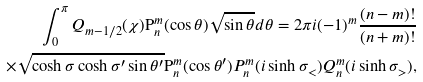Convert formula to latex. <formula><loc_0><loc_0><loc_500><loc_500>\int _ { 0 } ^ { \pi } Q _ { m - 1 / 2 } ( \chi ) { \mathrm P } _ { n } ^ { m } ( \cos \theta ) \sqrt { \sin \theta } d \theta = 2 \pi i ( - 1 ) ^ { m } \frac { ( n - m ) ! } { ( n + m ) ! } \\ \times \sqrt { \cosh \sigma \cosh \sigma ^ { \prime } \sin \theta ^ { \prime } } { \mathrm P } _ { n } ^ { m } ( \cos \theta ^ { \prime } ) P _ { n } ^ { m } ( i \sinh \sigma _ { < } ) Q _ { n } ^ { m } ( i \sinh \sigma _ { > } ) ,</formula> 